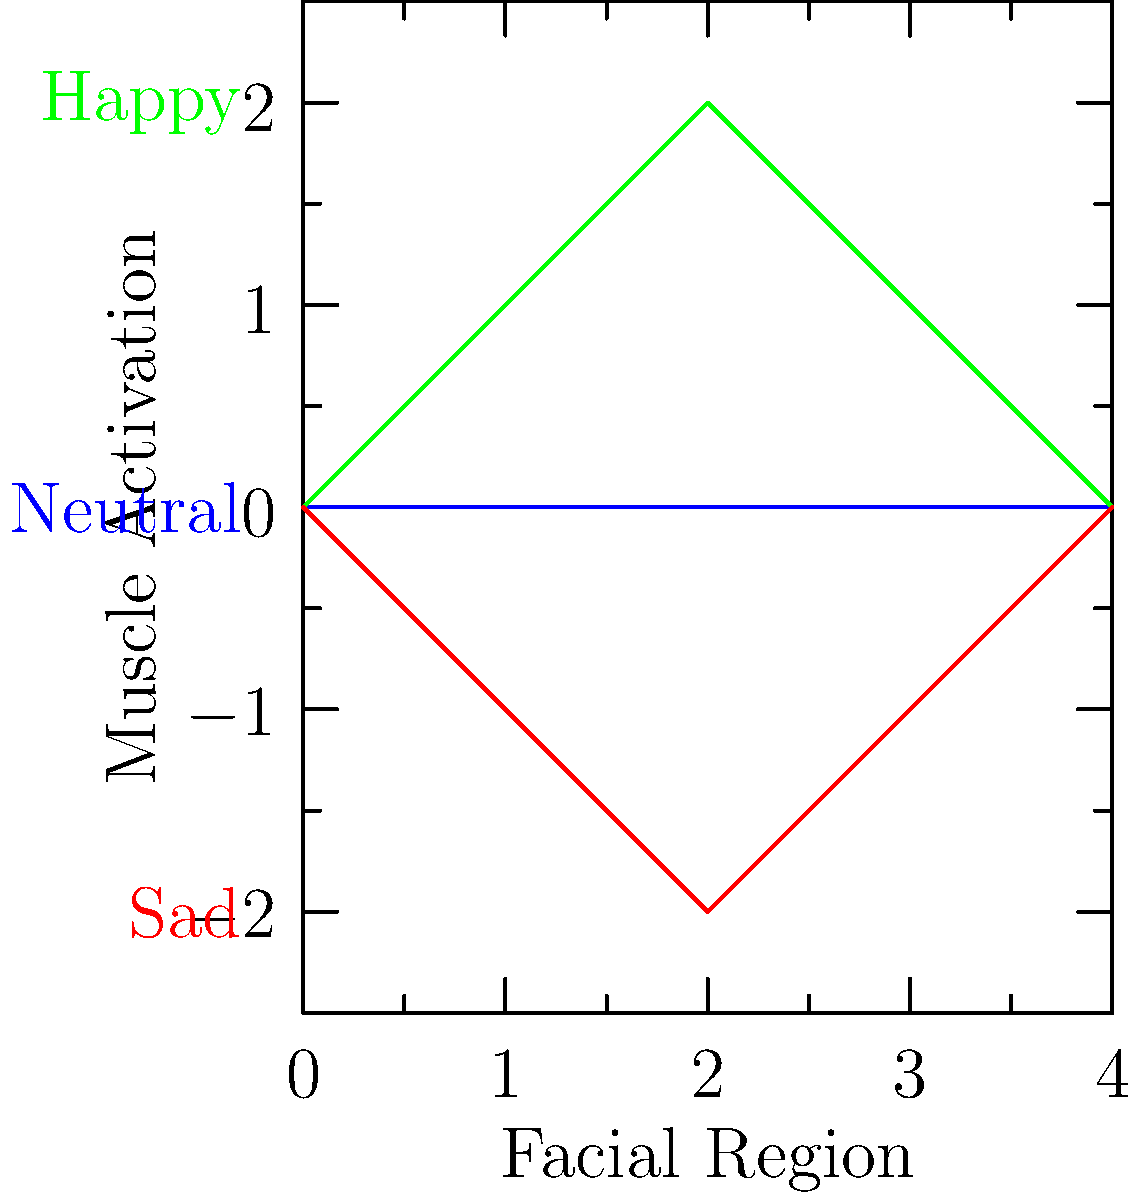Analyze the graph showing muscle activation patterns for different facial expressions. Which expression requires the most significant change in muscle activation compared to the neutral position, and in which facial region does this occur? To answer this question, we need to follow these steps:

1. Identify the different expressions represented in the graph:
   - Blue line: Neutral expression
   - Green line: Happy expression
   - Red line: Sad expression

2. Compare each expression to the neutral position:
   - Happy expression: Positive deviation from neutral
   - Sad expression: Negative deviation from neutral

3. Analyze the magnitude of change for each expression:
   - Happy expression: Maximum deviation of +2 units
   - Sad expression: Maximum deviation of -2 units

4. Determine the facial region with the most significant change:
   - Both happy and sad expressions show the maximum deviation at x = 2, which represents the middle of the face (likely the cheek/mouth area)

5. Compare the magnitude of change:
   - Both happy and sad expressions have the same maximum deviation of 2 units (absolute value)
   - However, the happy expression involves more overall muscle activation across the face

Therefore, the happy expression requires the most significant change in muscle activation compared to the neutral position, occurring in the middle facial region (cheek/mouth area).
Answer: Happy expression, cheek/mouth area 